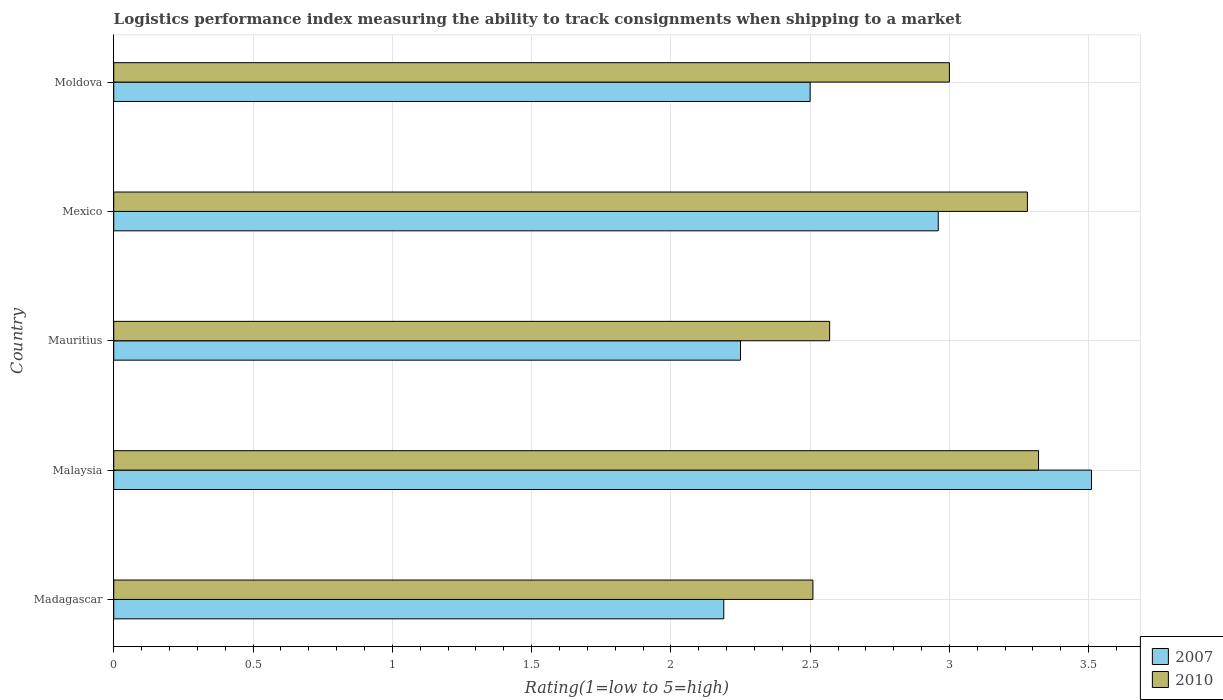How many groups of bars are there?
Ensure brevity in your answer.  5. Are the number of bars per tick equal to the number of legend labels?
Offer a terse response. Yes. What is the label of the 1st group of bars from the top?
Your response must be concise. Moldova. What is the Logistic performance index in 2010 in Madagascar?
Your answer should be very brief. 2.51. Across all countries, what is the maximum Logistic performance index in 2010?
Provide a succinct answer. 3.32. Across all countries, what is the minimum Logistic performance index in 2007?
Keep it short and to the point. 2.19. In which country was the Logistic performance index in 2007 maximum?
Provide a short and direct response. Malaysia. In which country was the Logistic performance index in 2010 minimum?
Make the answer very short. Madagascar. What is the total Logistic performance index in 2007 in the graph?
Your answer should be compact. 13.41. What is the difference between the Logistic performance index in 2007 in Mauritius and that in Mexico?
Give a very brief answer. -0.71. What is the difference between the Logistic performance index in 2007 in Moldova and the Logistic performance index in 2010 in Madagascar?
Your answer should be very brief. -0.01. What is the average Logistic performance index in 2007 per country?
Make the answer very short. 2.68. What is the difference between the Logistic performance index in 2010 and Logistic performance index in 2007 in Mauritius?
Offer a very short reply. 0.32. In how many countries, is the Logistic performance index in 2007 greater than 0.4 ?
Your answer should be very brief. 5. What is the ratio of the Logistic performance index in 2007 in Malaysia to that in Moldova?
Provide a short and direct response. 1.4. Is the Logistic performance index in 2007 in Madagascar less than that in Mexico?
Offer a terse response. Yes. What is the difference between the highest and the second highest Logistic performance index in 2010?
Your answer should be very brief. 0.04. What is the difference between the highest and the lowest Logistic performance index in 2010?
Ensure brevity in your answer.  0.81. In how many countries, is the Logistic performance index in 2007 greater than the average Logistic performance index in 2007 taken over all countries?
Give a very brief answer. 2. What does the 1st bar from the top in Madagascar represents?
Ensure brevity in your answer.  2010. How many countries are there in the graph?
Your answer should be compact. 5. What is the difference between two consecutive major ticks on the X-axis?
Give a very brief answer. 0.5. Does the graph contain grids?
Offer a terse response. Yes. How many legend labels are there?
Offer a terse response. 2. What is the title of the graph?
Ensure brevity in your answer.  Logistics performance index measuring the ability to track consignments when shipping to a market. What is the label or title of the X-axis?
Ensure brevity in your answer.  Rating(1=low to 5=high). What is the Rating(1=low to 5=high) of 2007 in Madagascar?
Ensure brevity in your answer.  2.19. What is the Rating(1=low to 5=high) in 2010 in Madagascar?
Provide a short and direct response. 2.51. What is the Rating(1=low to 5=high) in 2007 in Malaysia?
Your response must be concise. 3.51. What is the Rating(1=low to 5=high) of 2010 in Malaysia?
Provide a succinct answer. 3.32. What is the Rating(1=low to 5=high) in 2007 in Mauritius?
Your answer should be compact. 2.25. What is the Rating(1=low to 5=high) of 2010 in Mauritius?
Offer a very short reply. 2.57. What is the Rating(1=low to 5=high) in 2007 in Mexico?
Give a very brief answer. 2.96. What is the Rating(1=low to 5=high) of 2010 in Mexico?
Keep it short and to the point. 3.28. Across all countries, what is the maximum Rating(1=low to 5=high) of 2007?
Offer a very short reply. 3.51. Across all countries, what is the maximum Rating(1=low to 5=high) of 2010?
Your answer should be compact. 3.32. Across all countries, what is the minimum Rating(1=low to 5=high) in 2007?
Provide a short and direct response. 2.19. Across all countries, what is the minimum Rating(1=low to 5=high) of 2010?
Your answer should be very brief. 2.51. What is the total Rating(1=low to 5=high) in 2007 in the graph?
Keep it short and to the point. 13.41. What is the total Rating(1=low to 5=high) of 2010 in the graph?
Keep it short and to the point. 14.68. What is the difference between the Rating(1=low to 5=high) in 2007 in Madagascar and that in Malaysia?
Ensure brevity in your answer.  -1.32. What is the difference between the Rating(1=low to 5=high) in 2010 in Madagascar and that in Malaysia?
Provide a succinct answer. -0.81. What is the difference between the Rating(1=low to 5=high) in 2007 in Madagascar and that in Mauritius?
Ensure brevity in your answer.  -0.06. What is the difference between the Rating(1=low to 5=high) of 2010 in Madagascar and that in Mauritius?
Make the answer very short. -0.06. What is the difference between the Rating(1=low to 5=high) of 2007 in Madagascar and that in Mexico?
Provide a succinct answer. -0.77. What is the difference between the Rating(1=low to 5=high) of 2010 in Madagascar and that in Mexico?
Make the answer very short. -0.77. What is the difference between the Rating(1=low to 5=high) in 2007 in Madagascar and that in Moldova?
Your response must be concise. -0.31. What is the difference between the Rating(1=low to 5=high) of 2010 in Madagascar and that in Moldova?
Your answer should be compact. -0.49. What is the difference between the Rating(1=low to 5=high) in 2007 in Malaysia and that in Mauritius?
Make the answer very short. 1.26. What is the difference between the Rating(1=low to 5=high) of 2010 in Malaysia and that in Mauritius?
Give a very brief answer. 0.75. What is the difference between the Rating(1=low to 5=high) in 2007 in Malaysia and that in Mexico?
Offer a very short reply. 0.55. What is the difference between the Rating(1=low to 5=high) in 2010 in Malaysia and that in Moldova?
Give a very brief answer. 0.32. What is the difference between the Rating(1=low to 5=high) of 2007 in Mauritius and that in Mexico?
Offer a very short reply. -0.71. What is the difference between the Rating(1=low to 5=high) of 2010 in Mauritius and that in Mexico?
Your response must be concise. -0.71. What is the difference between the Rating(1=low to 5=high) of 2010 in Mauritius and that in Moldova?
Ensure brevity in your answer.  -0.43. What is the difference between the Rating(1=low to 5=high) of 2007 in Mexico and that in Moldova?
Offer a terse response. 0.46. What is the difference between the Rating(1=low to 5=high) of 2010 in Mexico and that in Moldova?
Give a very brief answer. 0.28. What is the difference between the Rating(1=low to 5=high) in 2007 in Madagascar and the Rating(1=low to 5=high) in 2010 in Malaysia?
Offer a very short reply. -1.13. What is the difference between the Rating(1=low to 5=high) in 2007 in Madagascar and the Rating(1=low to 5=high) in 2010 in Mauritius?
Your answer should be compact. -0.38. What is the difference between the Rating(1=low to 5=high) of 2007 in Madagascar and the Rating(1=low to 5=high) of 2010 in Mexico?
Your answer should be very brief. -1.09. What is the difference between the Rating(1=low to 5=high) of 2007 in Madagascar and the Rating(1=low to 5=high) of 2010 in Moldova?
Provide a succinct answer. -0.81. What is the difference between the Rating(1=low to 5=high) of 2007 in Malaysia and the Rating(1=low to 5=high) of 2010 in Mauritius?
Make the answer very short. 0.94. What is the difference between the Rating(1=low to 5=high) in 2007 in Malaysia and the Rating(1=low to 5=high) in 2010 in Mexico?
Ensure brevity in your answer.  0.23. What is the difference between the Rating(1=low to 5=high) of 2007 in Malaysia and the Rating(1=low to 5=high) of 2010 in Moldova?
Provide a short and direct response. 0.51. What is the difference between the Rating(1=low to 5=high) in 2007 in Mauritius and the Rating(1=low to 5=high) in 2010 in Mexico?
Keep it short and to the point. -1.03. What is the difference between the Rating(1=low to 5=high) of 2007 in Mauritius and the Rating(1=low to 5=high) of 2010 in Moldova?
Keep it short and to the point. -0.75. What is the difference between the Rating(1=low to 5=high) of 2007 in Mexico and the Rating(1=low to 5=high) of 2010 in Moldova?
Offer a terse response. -0.04. What is the average Rating(1=low to 5=high) of 2007 per country?
Ensure brevity in your answer.  2.68. What is the average Rating(1=low to 5=high) of 2010 per country?
Keep it short and to the point. 2.94. What is the difference between the Rating(1=low to 5=high) in 2007 and Rating(1=low to 5=high) in 2010 in Madagascar?
Offer a terse response. -0.32. What is the difference between the Rating(1=low to 5=high) in 2007 and Rating(1=low to 5=high) in 2010 in Malaysia?
Your answer should be very brief. 0.19. What is the difference between the Rating(1=low to 5=high) of 2007 and Rating(1=low to 5=high) of 2010 in Mauritius?
Make the answer very short. -0.32. What is the difference between the Rating(1=low to 5=high) of 2007 and Rating(1=low to 5=high) of 2010 in Mexico?
Keep it short and to the point. -0.32. What is the difference between the Rating(1=low to 5=high) in 2007 and Rating(1=low to 5=high) in 2010 in Moldova?
Your answer should be very brief. -0.5. What is the ratio of the Rating(1=low to 5=high) in 2007 in Madagascar to that in Malaysia?
Offer a very short reply. 0.62. What is the ratio of the Rating(1=low to 5=high) of 2010 in Madagascar to that in Malaysia?
Offer a terse response. 0.76. What is the ratio of the Rating(1=low to 5=high) in 2007 in Madagascar to that in Mauritius?
Provide a succinct answer. 0.97. What is the ratio of the Rating(1=low to 5=high) in 2010 in Madagascar to that in Mauritius?
Your response must be concise. 0.98. What is the ratio of the Rating(1=low to 5=high) in 2007 in Madagascar to that in Mexico?
Your response must be concise. 0.74. What is the ratio of the Rating(1=low to 5=high) in 2010 in Madagascar to that in Mexico?
Your answer should be compact. 0.77. What is the ratio of the Rating(1=low to 5=high) of 2007 in Madagascar to that in Moldova?
Ensure brevity in your answer.  0.88. What is the ratio of the Rating(1=low to 5=high) in 2010 in Madagascar to that in Moldova?
Provide a succinct answer. 0.84. What is the ratio of the Rating(1=low to 5=high) in 2007 in Malaysia to that in Mauritius?
Your answer should be very brief. 1.56. What is the ratio of the Rating(1=low to 5=high) of 2010 in Malaysia to that in Mauritius?
Provide a succinct answer. 1.29. What is the ratio of the Rating(1=low to 5=high) of 2007 in Malaysia to that in Mexico?
Give a very brief answer. 1.19. What is the ratio of the Rating(1=low to 5=high) in 2010 in Malaysia to that in Mexico?
Provide a short and direct response. 1.01. What is the ratio of the Rating(1=low to 5=high) of 2007 in Malaysia to that in Moldova?
Make the answer very short. 1.4. What is the ratio of the Rating(1=low to 5=high) in 2010 in Malaysia to that in Moldova?
Give a very brief answer. 1.11. What is the ratio of the Rating(1=low to 5=high) of 2007 in Mauritius to that in Mexico?
Provide a short and direct response. 0.76. What is the ratio of the Rating(1=low to 5=high) in 2010 in Mauritius to that in Mexico?
Keep it short and to the point. 0.78. What is the ratio of the Rating(1=low to 5=high) in 2010 in Mauritius to that in Moldova?
Your answer should be compact. 0.86. What is the ratio of the Rating(1=low to 5=high) of 2007 in Mexico to that in Moldova?
Offer a terse response. 1.18. What is the ratio of the Rating(1=low to 5=high) of 2010 in Mexico to that in Moldova?
Your response must be concise. 1.09. What is the difference between the highest and the second highest Rating(1=low to 5=high) in 2007?
Make the answer very short. 0.55. What is the difference between the highest and the lowest Rating(1=low to 5=high) in 2007?
Make the answer very short. 1.32. What is the difference between the highest and the lowest Rating(1=low to 5=high) in 2010?
Keep it short and to the point. 0.81. 